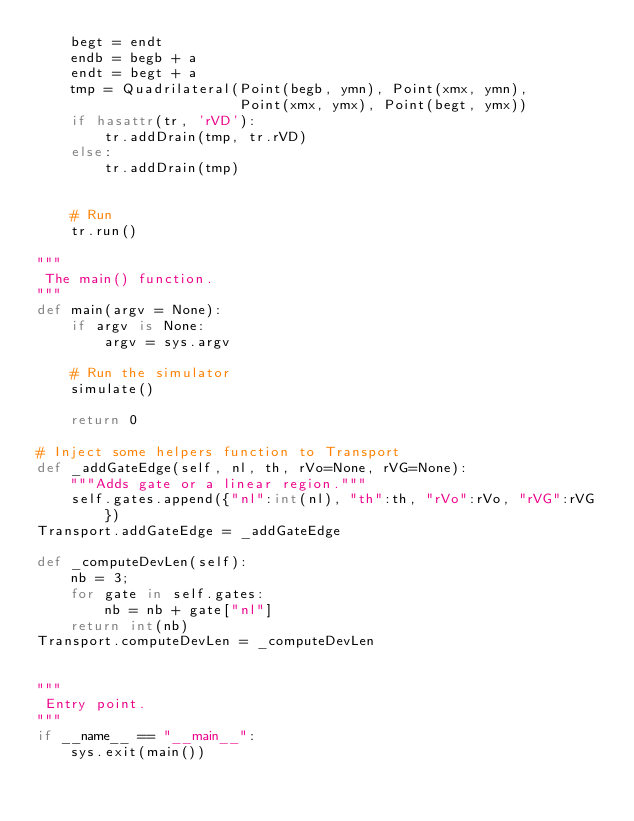<code> <loc_0><loc_0><loc_500><loc_500><_Python_>    begt = endt
    endb = begb + a
    endt = begt + a
    tmp = Quadrilateral(Point(begb, ymn), Point(xmx, ymn),
                        Point(xmx, ymx), Point(begt, ymx))
    if hasattr(tr, 'rVD'):
        tr.addDrain(tmp, tr.rVD)
    else:
        tr.addDrain(tmp)

            
    # Run
    tr.run()

"""
 The main() function.
"""
def main(argv = None):
    if argv is None:
        argv = sys.argv

    # Run the simulator
    simulate()
        
    return 0

# Inject some helpers function to Transport
def _addGateEdge(self, nl, th, rVo=None, rVG=None):
    """Adds gate or a linear region."""
    self.gates.append({"nl":int(nl), "th":th, "rVo":rVo, "rVG":rVG})
Transport.addGateEdge = _addGateEdge

def _computeDevLen(self):
    nb = 3;
    for gate in self.gates:
        nb = nb + gate["nl"]
    return int(nb)
Transport.computeDevLen = _computeDevLen


"""
 Entry point.
"""
if __name__ == "__main__":
    sys.exit(main())



</code> 